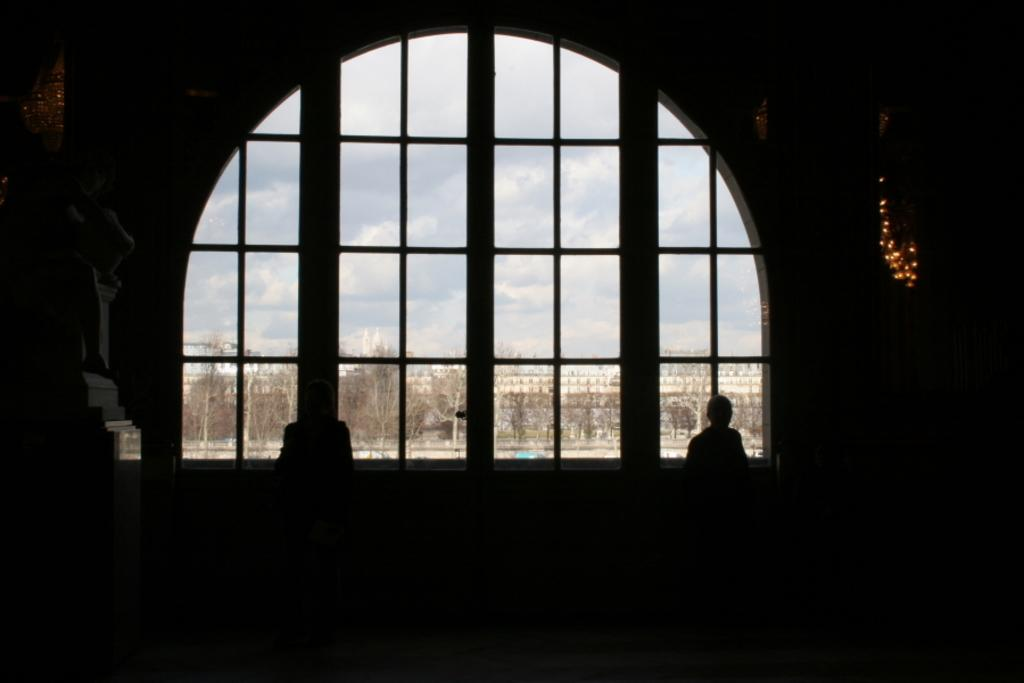What is located in the center of the image? There is a window in the center of the image. What can be seen through the window? Trees and buildings are visible through the window. Can you describe the person in the image? There is a person in the image, but their appearance or actions are not specified. What other items are present in the image? There are objects in the image, but their nature or purpose is not mentioned. How would you describe the lighting in the foreground of the image? The foreground of the image is dark. How many spies can be seen in the image? There is no mention of spies in the image; it only features a window, trees, buildings, a person, and objects. What type of finger is visible in the image? There is no finger visible in the image. 